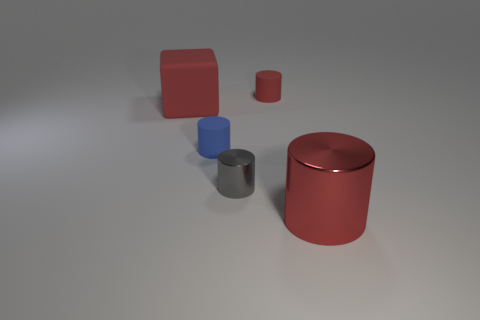The big rubber thing that is the same color as the big cylinder is what shape?
Provide a short and direct response. Cube. Is the red cylinder left of the large cylinder made of the same material as the big thing that is right of the blue cylinder?
Provide a succinct answer. No. What is the material of the large cylinder that is the same color as the big matte block?
Offer a terse response. Metal. Are there any cylinders that have the same color as the rubber block?
Ensure brevity in your answer.  Yes. Are the small gray object and the blue object made of the same material?
Your answer should be compact. No. There is a tiny blue thing; how many small blue matte objects are to the right of it?
Offer a terse response. 0. What color is the other large shiny object that is the same shape as the blue thing?
Make the answer very short. Red. What material is the cylinder that is both to the right of the tiny gray metal cylinder and in front of the blue cylinder?
Your answer should be compact. Metal. Do the blue object that is behind the gray metal cylinder and the large red matte cube have the same size?
Ensure brevity in your answer.  No. What material is the blue thing?
Make the answer very short. Rubber. 